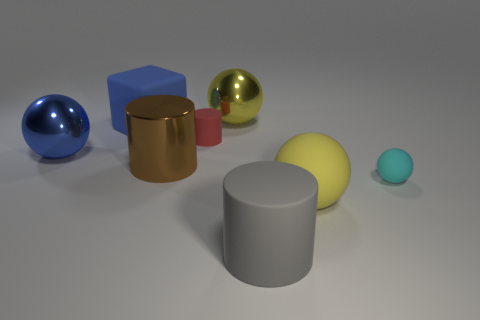Subtract all cylinders. How many objects are left? 5 Subtract 4 balls. How many balls are left? 0 Subtract all yellow cylinders. Subtract all yellow balls. How many cylinders are left? 3 Subtract all gray blocks. How many gray cylinders are left? 1 Subtract all tiny blue rubber objects. Subtract all large brown metal things. How many objects are left? 7 Add 6 large blue things. How many large blue things are left? 8 Add 6 small cyan matte things. How many small cyan matte things exist? 7 Add 2 small cyan things. How many objects exist? 10 Subtract all cyan spheres. How many spheres are left? 3 Subtract all large matte cylinders. How many cylinders are left? 2 